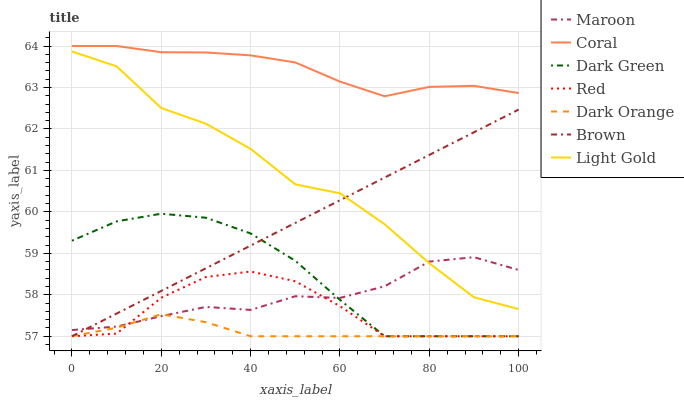Does Dark Orange have the minimum area under the curve?
Answer yes or no. Yes. Does Coral have the maximum area under the curve?
Answer yes or no. Yes. Does Coral have the minimum area under the curve?
Answer yes or no. No. Does Dark Orange have the maximum area under the curve?
Answer yes or no. No. Is Brown the smoothest?
Answer yes or no. Yes. Is Light Gold the roughest?
Answer yes or no. Yes. Is Dark Orange the smoothest?
Answer yes or no. No. Is Dark Orange the roughest?
Answer yes or no. No. Does Brown have the lowest value?
Answer yes or no. Yes. Does Coral have the lowest value?
Answer yes or no. No. Does Coral have the highest value?
Answer yes or no. Yes. Does Dark Orange have the highest value?
Answer yes or no. No. Is Dark Orange less than Coral?
Answer yes or no. Yes. Is Coral greater than Maroon?
Answer yes or no. Yes. Does Red intersect Dark Orange?
Answer yes or no. Yes. Is Red less than Dark Orange?
Answer yes or no. No. Is Red greater than Dark Orange?
Answer yes or no. No. Does Dark Orange intersect Coral?
Answer yes or no. No. 